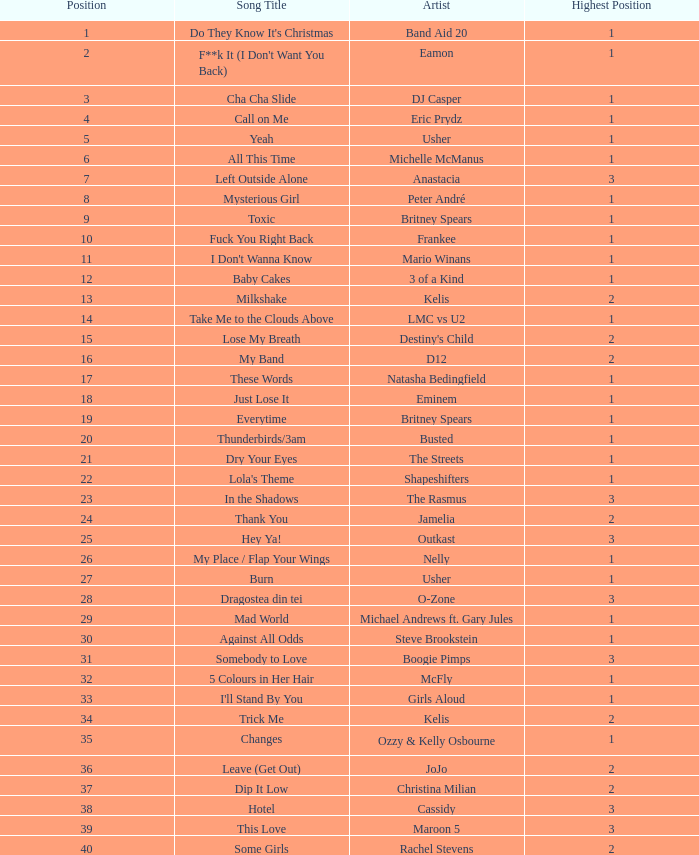What is the top sales figure for a song positioned beyond 3? None. 